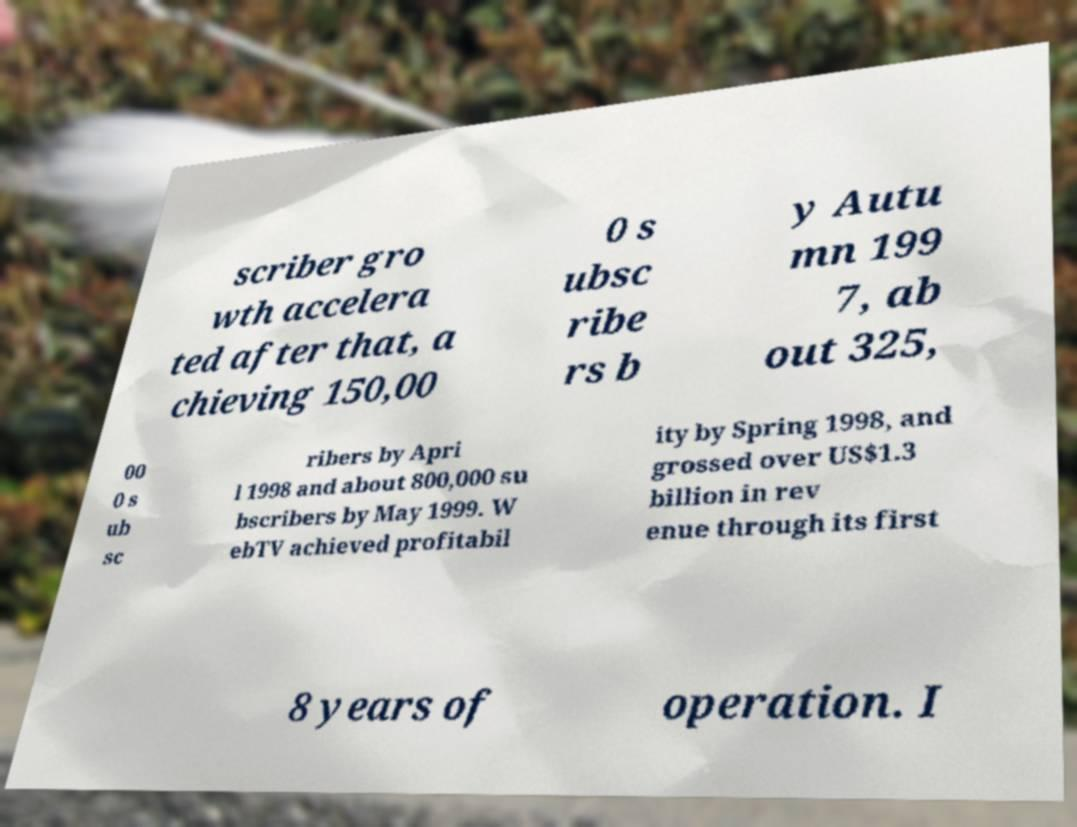Can you read and provide the text displayed in the image?This photo seems to have some interesting text. Can you extract and type it out for me? scriber gro wth accelera ted after that, a chieving 150,00 0 s ubsc ribe rs b y Autu mn 199 7, ab out 325, 00 0 s ub sc ribers by Apri l 1998 and about 800,000 su bscribers by May 1999. W ebTV achieved profitabil ity by Spring 1998, and grossed over US$1.3 billion in rev enue through its first 8 years of operation. I 